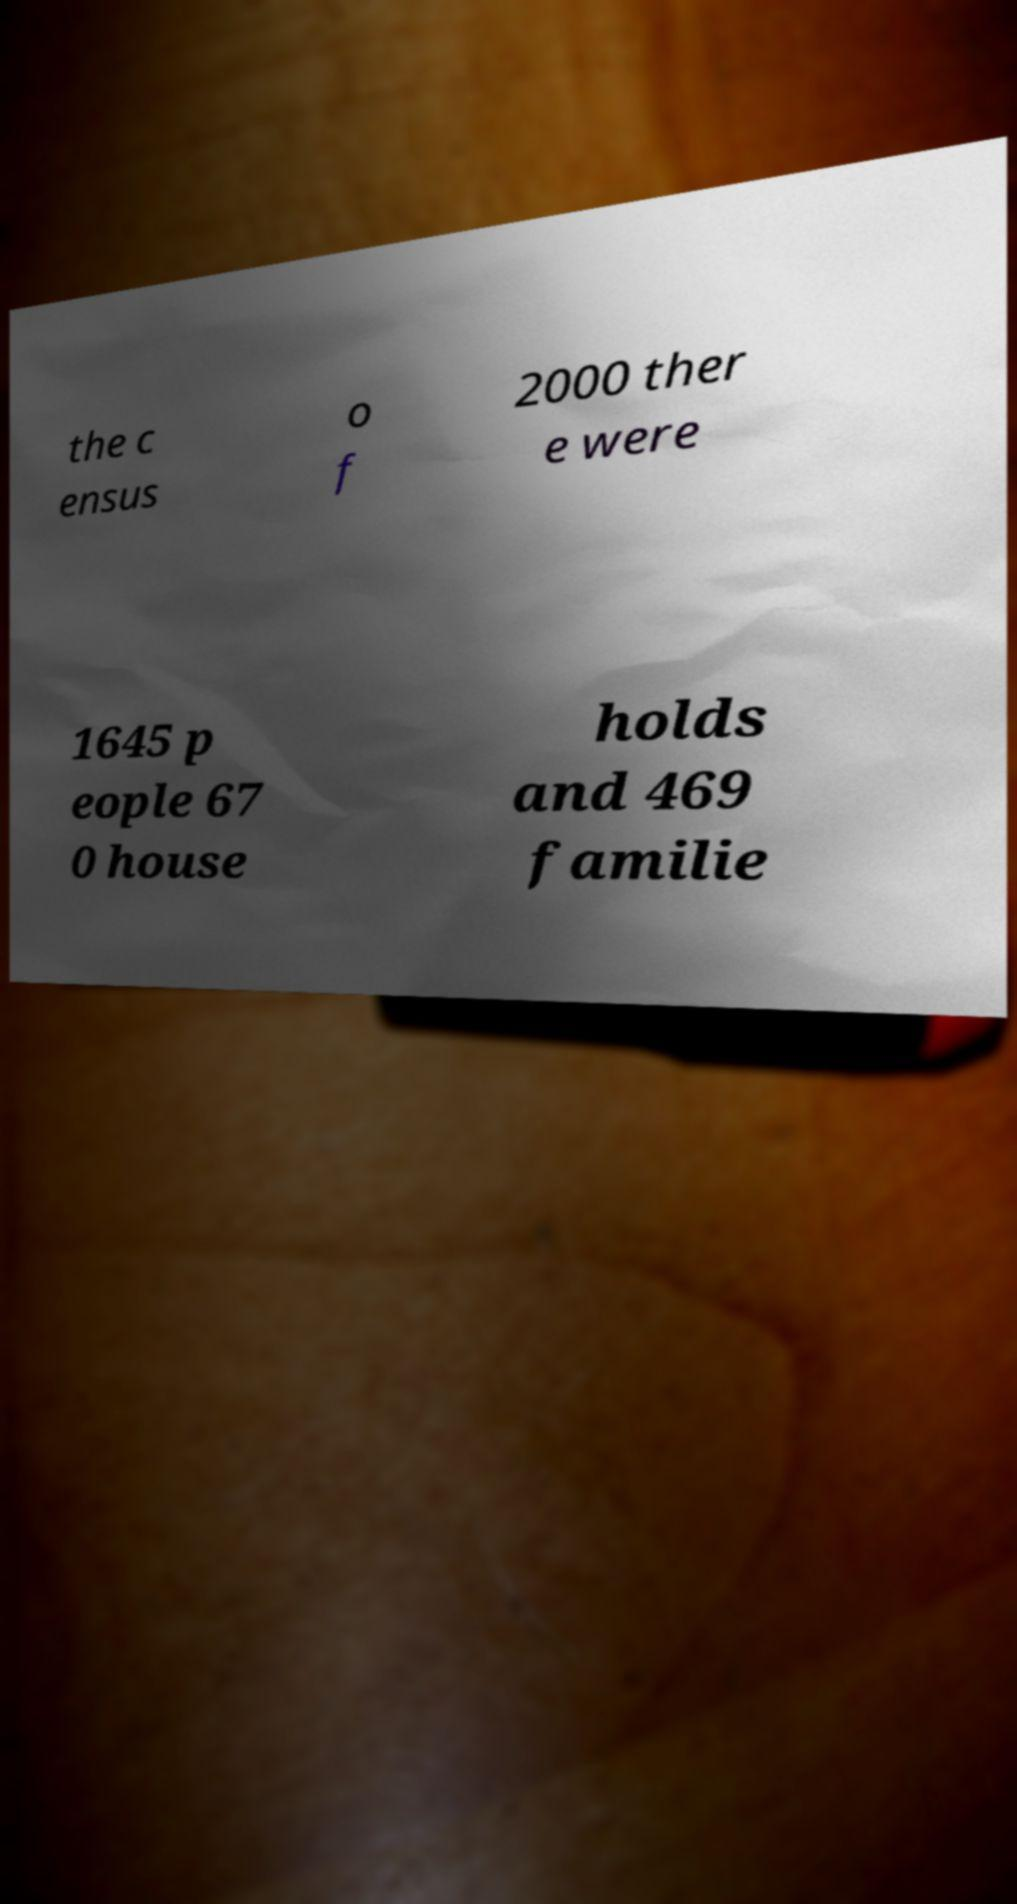Can you read and provide the text displayed in the image?This photo seems to have some interesting text. Can you extract and type it out for me? the c ensus o f 2000 ther e were 1645 p eople 67 0 house holds and 469 familie 